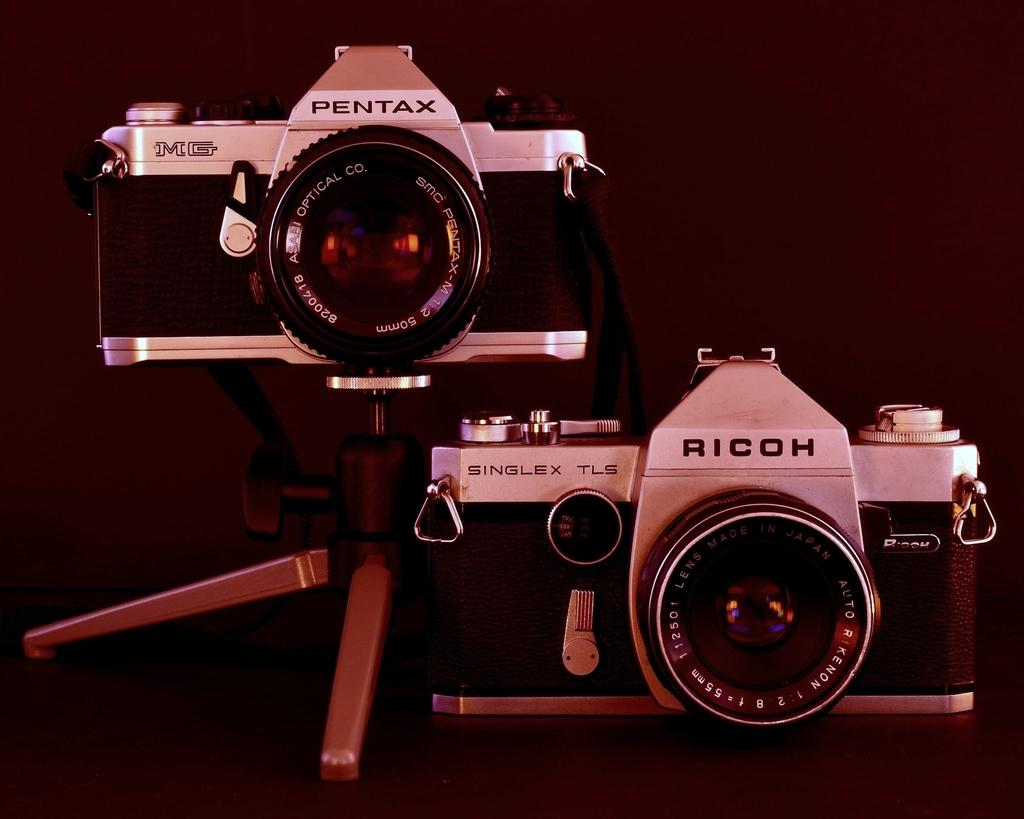What is the main object in the image? There is a camera in the image. Are there any other cameras visible in the image? Yes, there is another camera with a stand in the image. What can be seen on the cameras? Something is written on the cameras. How does the family behave in the image? There is no family present in the image, so it is not possible to determine their behavior. 